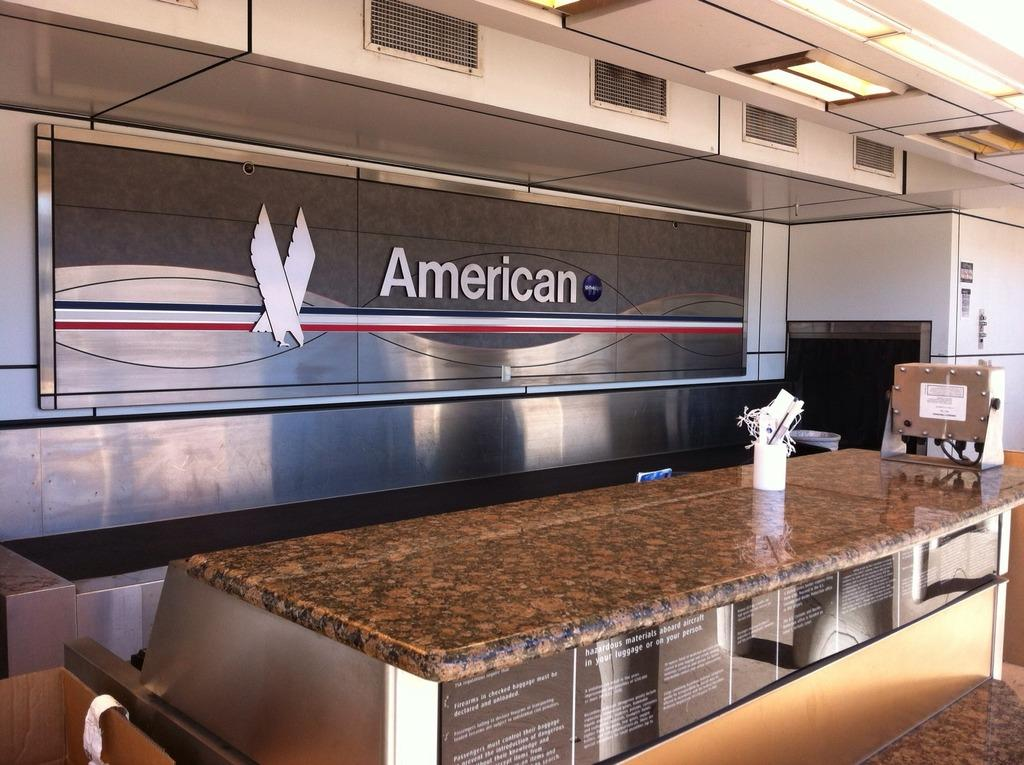What surface is visible in the image? There is a countertop in the image. What object is placed on the countertop? There is a pen stand on the countertop. What type of object is visible in the image besides the countertop and pen stand? There is a board in the image. What can be seen at the top of the image? There are lights at the top of the image. What type of meat is being cooked on the countertop in the image? There is no meat or cooking activity present in the image; it features a countertop, pen stand, board, and lights. 